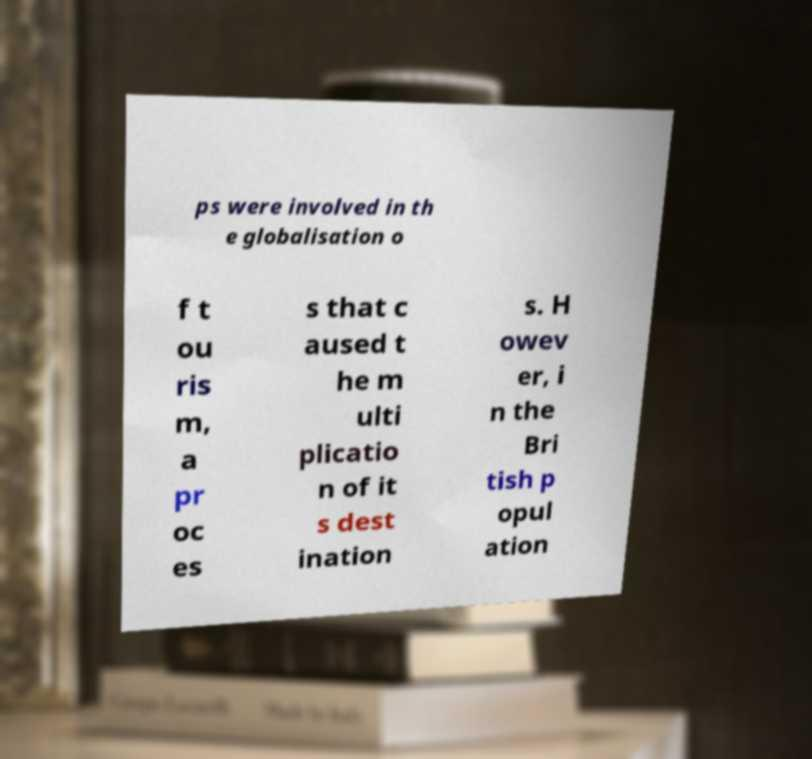Can you accurately transcribe the text from the provided image for me? ps were involved in th e globalisation o f t ou ris m, a pr oc es s that c aused t he m ulti plicatio n of it s dest ination s. H owev er, i n the Bri tish p opul ation 